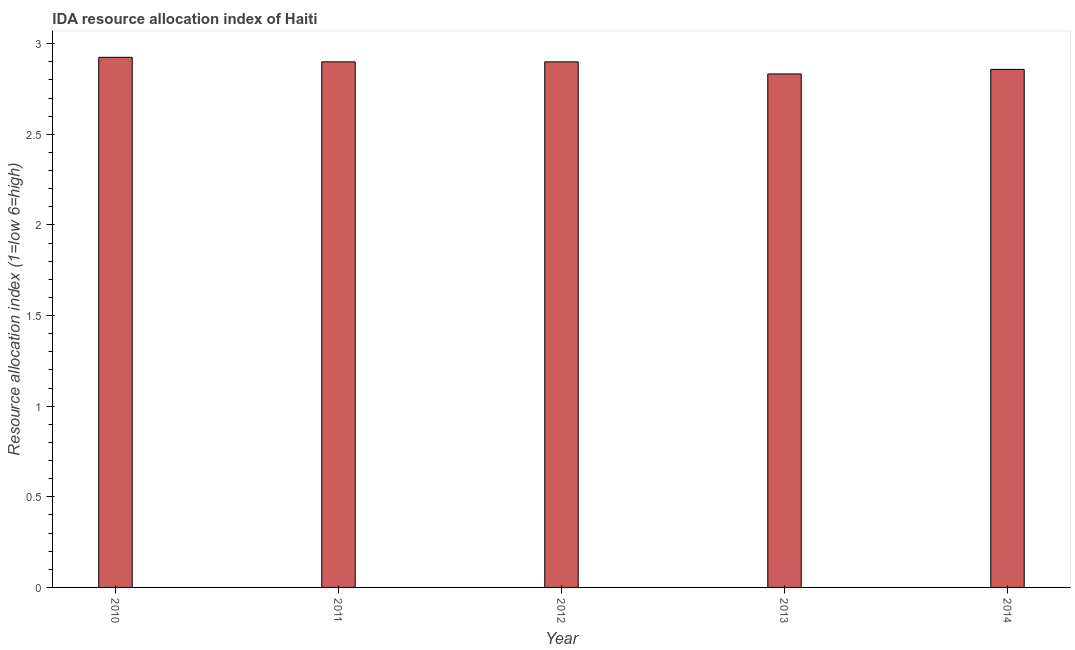Does the graph contain any zero values?
Keep it short and to the point. No. Does the graph contain grids?
Your answer should be compact. No. What is the title of the graph?
Give a very brief answer. IDA resource allocation index of Haiti. What is the label or title of the Y-axis?
Offer a terse response. Resource allocation index (1=low 6=high). What is the ida resource allocation index in 2014?
Provide a short and direct response. 2.86. Across all years, what is the maximum ida resource allocation index?
Provide a short and direct response. 2.92. Across all years, what is the minimum ida resource allocation index?
Offer a very short reply. 2.83. In which year was the ida resource allocation index maximum?
Provide a succinct answer. 2010. In which year was the ida resource allocation index minimum?
Provide a succinct answer. 2013. What is the sum of the ida resource allocation index?
Provide a succinct answer. 14.42. What is the difference between the ida resource allocation index in 2013 and 2014?
Keep it short and to the point. -0.03. What is the average ida resource allocation index per year?
Make the answer very short. 2.88. In how many years, is the ida resource allocation index greater than 0.3 ?
Provide a short and direct response. 5. What is the ratio of the ida resource allocation index in 2010 to that in 2013?
Keep it short and to the point. 1.03. Is the ida resource allocation index in 2011 less than that in 2014?
Your response must be concise. No. What is the difference between the highest and the second highest ida resource allocation index?
Keep it short and to the point. 0.03. Is the sum of the ida resource allocation index in 2011 and 2013 greater than the maximum ida resource allocation index across all years?
Provide a short and direct response. Yes. What is the difference between the highest and the lowest ida resource allocation index?
Provide a short and direct response. 0.09. Are all the bars in the graph horizontal?
Ensure brevity in your answer.  No. How many years are there in the graph?
Make the answer very short. 5. Are the values on the major ticks of Y-axis written in scientific E-notation?
Ensure brevity in your answer.  No. What is the Resource allocation index (1=low 6=high) of 2010?
Your response must be concise. 2.92. What is the Resource allocation index (1=low 6=high) of 2011?
Keep it short and to the point. 2.9. What is the Resource allocation index (1=low 6=high) in 2012?
Ensure brevity in your answer.  2.9. What is the Resource allocation index (1=low 6=high) of 2013?
Make the answer very short. 2.83. What is the Resource allocation index (1=low 6=high) in 2014?
Provide a short and direct response. 2.86. What is the difference between the Resource allocation index (1=low 6=high) in 2010 and 2011?
Offer a terse response. 0.03. What is the difference between the Resource allocation index (1=low 6=high) in 2010 and 2012?
Provide a succinct answer. 0.03. What is the difference between the Resource allocation index (1=low 6=high) in 2010 and 2013?
Offer a terse response. 0.09. What is the difference between the Resource allocation index (1=low 6=high) in 2010 and 2014?
Keep it short and to the point. 0.07. What is the difference between the Resource allocation index (1=low 6=high) in 2011 and 2012?
Offer a terse response. 0. What is the difference between the Resource allocation index (1=low 6=high) in 2011 and 2013?
Ensure brevity in your answer.  0.07. What is the difference between the Resource allocation index (1=low 6=high) in 2011 and 2014?
Keep it short and to the point. 0.04. What is the difference between the Resource allocation index (1=low 6=high) in 2012 and 2013?
Keep it short and to the point. 0.07. What is the difference between the Resource allocation index (1=low 6=high) in 2012 and 2014?
Your response must be concise. 0.04. What is the difference between the Resource allocation index (1=low 6=high) in 2013 and 2014?
Provide a succinct answer. -0.03. What is the ratio of the Resource allocation index (1=low 6=high) in 2010 to that in 2011?
Offer a very short reply. 1.01. What is the ratio of the Resource allocation index (1=low 6=high) in 2010 to that in 2012?
Your answer should be very brief. 1.01. What is the ratio of the Resource allocation index (1=low 6=high) in 2010 to that in 2013?
Your answer should be very brief. 1.03. What is the ratio of the Resource allocation index (1=low 6=high) in 2010 to that in 2014?
Ensure brevity in your answer.  1.02. What is the ratio of the Resource allocation index (1=low 6=high) in 2012 to that in 2013?
Offer a terse response. 1.02. What is the ratio of the Resource allocation index (1=low 6=high) in 2012 to that in 2014?
Your answer should be compact. 1.01. What is the ratio of the Resource allocation index (1=low 6=high) in 2013 to that in 2014?
Offer a very short reply. 0.99. 